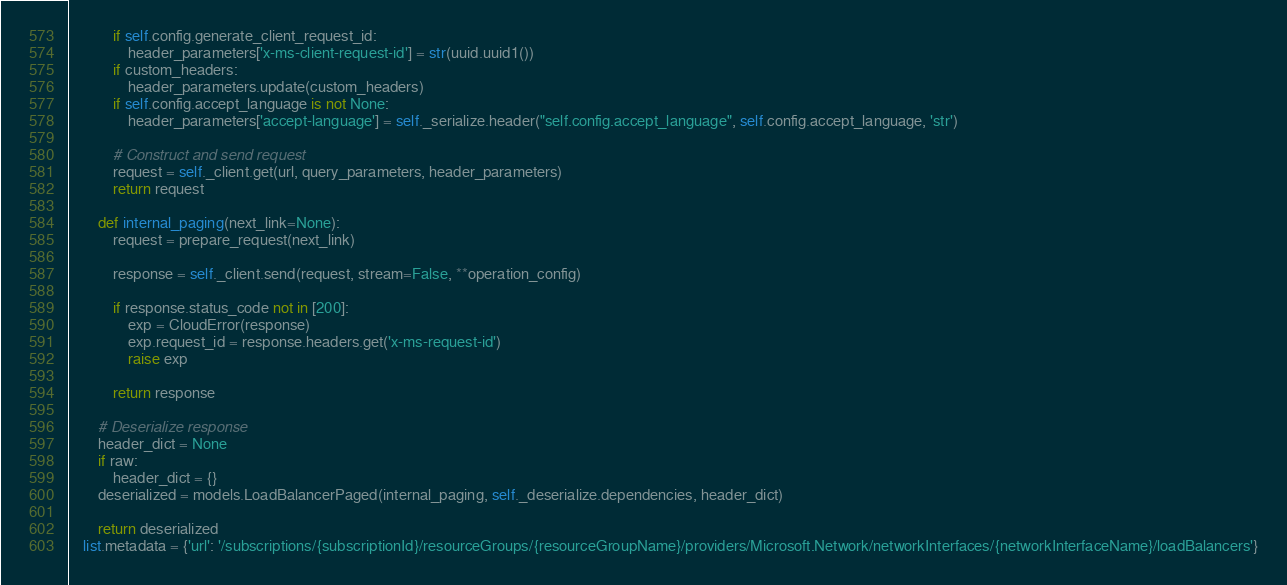Convert code to text. <code><loc_0><loc_0><loc_500><loc_500><_Python_>            if self.config.generate_client_request_id:
                header_parameters['x-ms-client-request-id'] = str(uuid.uuid1())
            if custom_headers:
                header_parameters.update(custom_headers)
            if self.config.accept_language is not None:
                header_parameters['accept-language'] = self._serialize.header("self.config.accept_language", self.config.accept_language, 'str')

            # Construct and send request
            request = self._client.get(url, query_parameters, header_parameters)
            return request

        def internal_paging(next_link=None):
            request = prepare_request(next_link)

            response = self._client.send(request, stream=False, **operation_config)

            if response.status_code not in [200]:
                exp = CloudError(response)
                exp.request_id = response.headers.get('x-ms-request-id')
                raise exp

            return response

        # Deserialize response
        header_dict = None
        if raw:
            header_dict = {}
        deserialized = models.LoadBalancerPaged(internal_paging, self._deserialize.dependencies, header_dict)

        return deserialized
    list.metadata = {'url': '/subscriptions/{subscriptionId}/resourceGroups/{resourceGroupName}/providers/Microsoft.Network/networkInterfaces/{networkInterfaceName}/loadBalancers'}
</code> 